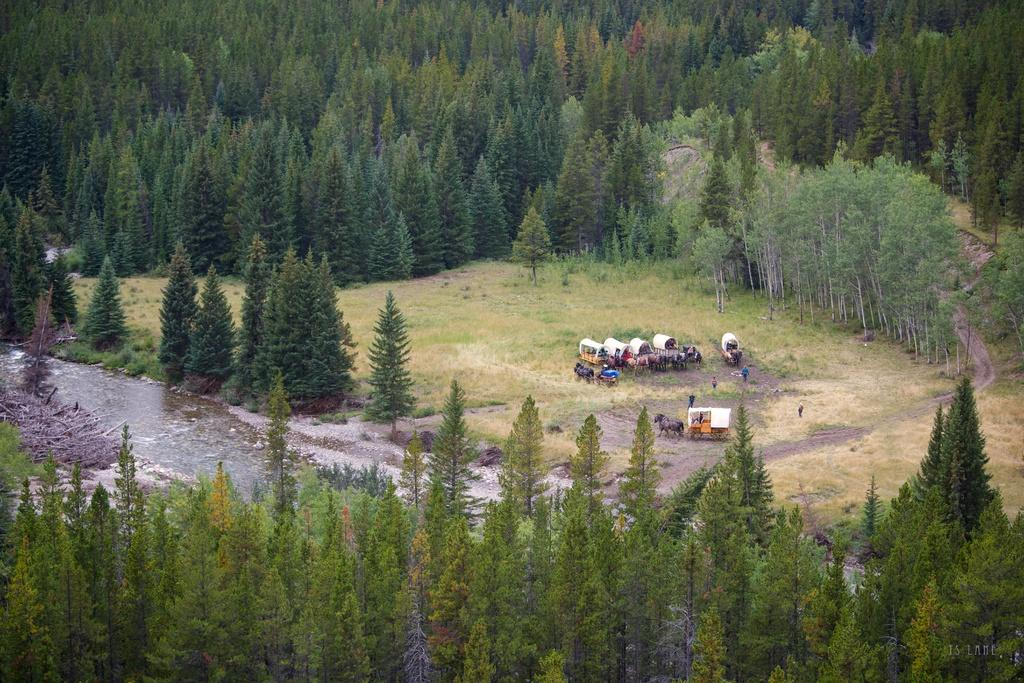What type of vehicles are in the image? There are horse carts in the image. What else can be seen on the ground in the image? There are people on the ground in the image. What type of vegetation is present in the image? There are trees and grass in the image. What natural element is visible in the image? There is water visible in the image. What other objects are on the ground in the image? There are other objects on the ground in the image. What idea can be seen sparking in the image? There is no idea or spark present in the image; it features horse carts, people, trees, grass, water, and other objects on the ground. Can you tell me how many flies are visible in the image? A: There are no flies present in the image. 